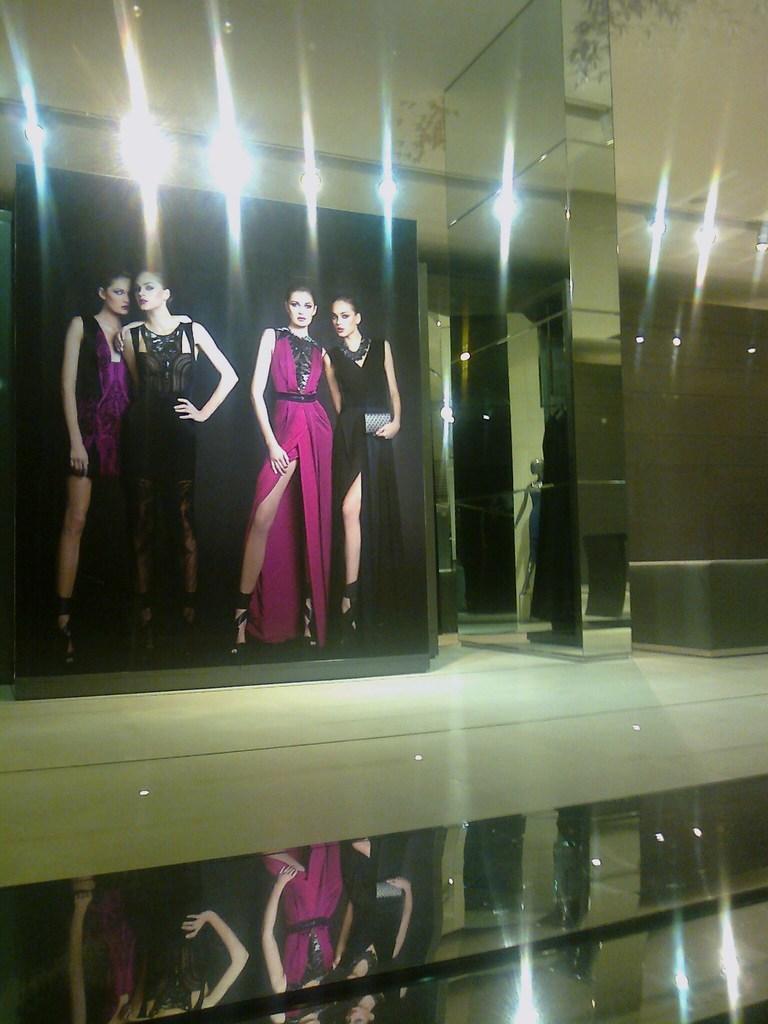How would you summarize this image in a sentence or two? This image consists of a poster on which there are pictures of the women. At the bottom, there is a floor. And we can see the reflection of the poster on the floor. On the right, there is a pillar along with mirrors. At the top, there are lights to the roof. 